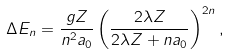Convert formula to latex. <formula><loc_0><loc_0><loc_500><loc_500>\Delta E _ { n } = \frac { g Z } { n ^ { 2 } a _ { 0 } } \left ( \frac { 2 \lambda Z } { 2 \lambda Z + n a _ { 0 } } \right ) ^ { 2 n } ,</formula> 